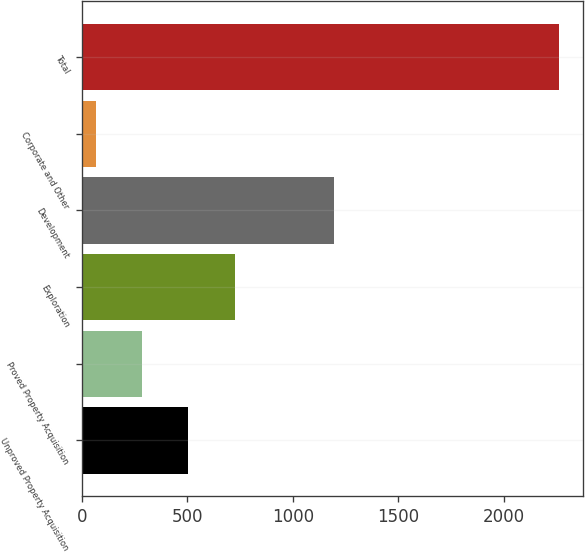<chart> <loc_0><loc_0><loc_500><loc_500><bar_chart><fcel>Unproved Property Acquisition<fcel>Proved Property Acquisition<fcel>Exploration<fcel>Development<fcel>Corporate and Other<fcel>Total<nl><fcel>504.8<fcel>284.9<fcel>724.7<fcel>1193<fcel>65<fcel>2264<nl></chart> 